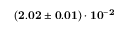Convert formula to latex. <formula><loc_0><loc_0><loc_500><loc_500>( 2 . 0 2 \pm 0 . 0 1 ) \cdot 1 0 ^ { - 2 }</formula> 